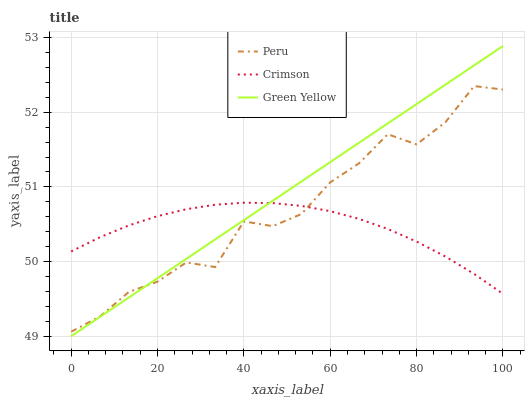Does Crimson have the minimum area under the curve?
Answer yes or no. Yes. Does Green Yellow have the maximum area under the curve?
Answer yes or no. Yes. Does Peru have the minimum area under the curve?
Answer yes or no. No. Does Peru have the maximum area under the curve?
Answer yes or no. No. Is Green Yellow the smoothest?
Answer yes or no. Yes. Is Peru the roughest?
Answer yes or no. Yes. Is Peru the smoothest?
Answer yes or no. No. Is Green Yellow the roughest?
Answer yes or no. No. Does Green Yellow have the lowest value?
Answer yes or no. Yes. Does Peru have the lowest value?
Answer yes or no. No. Does Green Yellow have the highest value?
Answer yes or no. Yes. Does Peru have the highest value?
Answer yes or no. No. Does Green Yellow intersect Peru?
Answer yes or no. Yes. Is Green Yellow less than Peru?
Answer yes or no. No. Is Green Yellow greater than Peru?
Answer yes or no. No. 